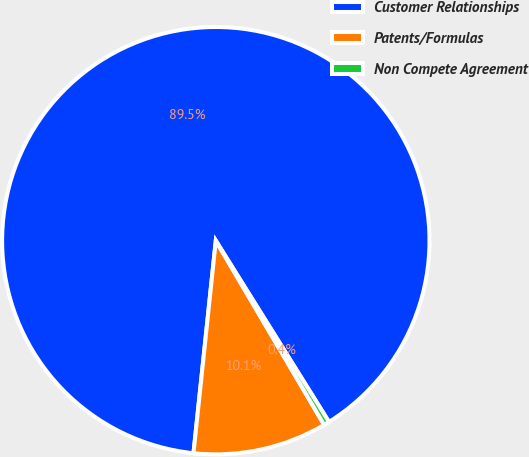<chart> <loc_0><loc_0><loc_500><loc_500><pie_chart><fcel>Customer Relationships<fcel>Patents/Formulas<fcel>Non Compete Agreement<nl><fcel>89.45%<fcel>10.13%<fcel>0.42%<nl></chart> 